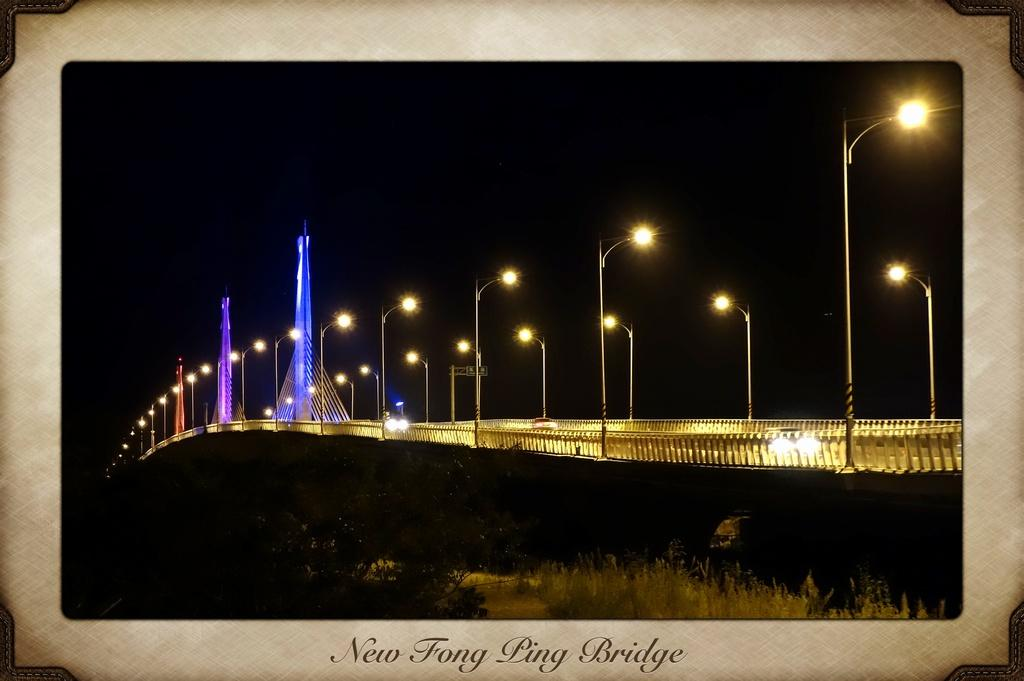What is the main subject in the center of the image? There is a frame in the center of the image. What types of objects are contained within the frame? The frame contains plants, fences, poles, lights, and banners. Is there any text present on the frame? Yes, there is text written on the frame. Can you tell me how many sheep are visible in the image? There are no sheep present in the image. What type of root system do the plants in the frame have? The provided facts do not mention the root system of the plants in the frame. 